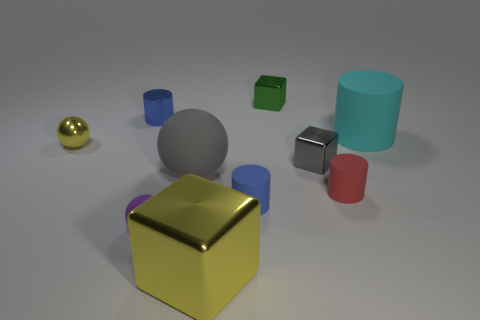Do the purple object left of the large gray rubber ball and the red cylinder have the same material?
Keep it short and to the point. Yes. What size is the blue object that is to the right of the tiny blue thing that is to the left of the small blue cylinder that is in front of the large cyan rubber object?
Offer a very short reply. Small. How many other objects are there of the same color as the large shiny cube?
Your response must be concise. 1. There is a yellow shiny object that is the same size as the gray ball; what shape is it?
Make the answer very short. Cube. How big is the cyan thing on the right side of the green shiny cube?
Your answer should be compact. Large. There is a cylinder that is on the left side of the purple matte sphere; is it the same color as the cube to the right of the green thing?
Keep it short and to the point. No. The tiny sphere that is right of the cylinder that is to the left of the sphere that is in front of the gray matte ball is made of what material?
Keep it short and to the point. Rubber. Is there a metallic sphere that has the same size as the cyan cylinder?
Make the answer very short. No. There is a yellow thing that is the same size as the green shiny cube; what material is it?
Offer a terse response. Metal. What shape is the big yellow thing in front of the small red matte cylinder?
Provide a short and direct response. Cube. 